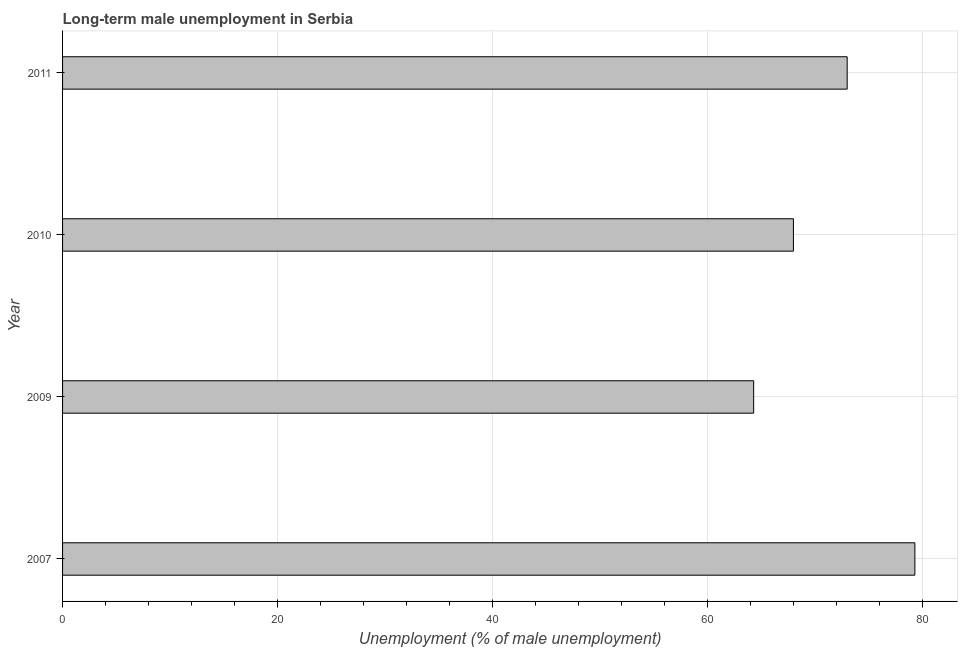Does the graph contain any zero values?
Ensure brevity in your answer.  No. Does the graph contain grids?
Make the answer very short. Yes. What is the title of the graph?
Your answer should be very brief. Long-term male unemployment in Serbia. What is the label or title of the X-axis?
Provide a short and direct response. Unemployment (% of male unemployment). What is the label or title of the Y-axis?
Your answer should be compact. Year. Across all years, what is the maximum long-term male unemployment?
Ensure brevity in your answer.  79.3. Across all years, what is the minimum long-term male unemployment?
Ensure brevity in your answer.  64.3. What is the sum of the long-term male unemployment?
Your response must be concise. 284.6. What is the difference between the long-term male unemployment in 2009 and 2010?
Your answer should be very brief. -3.7. What is the average long-term male unemployment per year?
Offer a very short reply. 71.15. What is the median long-term male unemployment?
Your response must be concise. 70.5. Do a majority of the years between 2011 and 2007 (inclusive) have long-term male unemployment greater than 44 %?
Ensure brevity in your answer.  Yes. What is the ratio of the long-term male unemployment in 2009 to that in 2010?
Offer a terse response. 0.95. What is the difference between the highest and the second highest long-term male unemployment?
Keep it short and to the point. 6.3. Is the sum of the long-term male unemployment in 2007 and 2010 greater than the maximum long-term male unemployment across all years?
Your response must be concise. Yes. In how many years, is the long-term male unemployment greater than the average long-term male unemployment taken over all years?
Offer a very short reply. 2. How many bars are there?
Provide a succinct answer. 4. Are all the bars in the graph horizontal?
Ensure brevity in your answer.  Yes. What is the difference between two consecutive major ticks on the X-axis?
Ensure brevity in your answer.  20. What is the Unemployment (% of male unemployment) in 2007?
Provide a succinct answer. 79.3. What is the Unemployment (% of male unemployment) of 2009?
Offer a very short reply. 64.3. What is the Unemployment (% of male unemployment) in 2011?
Your answer should be very brief. 73. What is the difference between the Unemployment (% of male unemployment) in 2007 and 2009?
Offer a terse response. 15. What is the difference between the Unemployment (% of male unemployment) in 2007 and 2010?
Make the answer very short. 11.3. What is the difference between the Unemployment (% of male unemployment) in 2007 and 2011?
Give a very brief answer. 6.3. What is the difference between the Unemployment (% of male unemployment) in 2009 and 2010?
Your response must be concise. -3.7. What is the difference between the Unemployment (% of male unemployment) in 2009 and 2011?
Ensure brevity in your answer.  -8.7. What is the ratio of the Unemployment (% of male unemployment) in 2007 to that in 2009?
Provide a succinct answer. 1.23. What is the ratio of the Unemployment (% of male unemployment) in 2007 to that in 2010?
Give a very brief answer. 1.17. What is the ratio of the Unemployment (% of male unemployment) in 2007 to that in 2011?
Provide a short and direct response. 1.09. What is the ratio of the Unemployment (% of male unemployment) in 2009 to that in 2010?
Offer a terse response. 0.95. What is the ratio of the Unemployment (% of male unemployment) in 2009 to that in 2011?
Your answer should be very brief. 0.88. What is the ratio of the Unemployment (% of male unemployment) in 2010 to that in 2011?
Give a very brief answer. 0.93. 